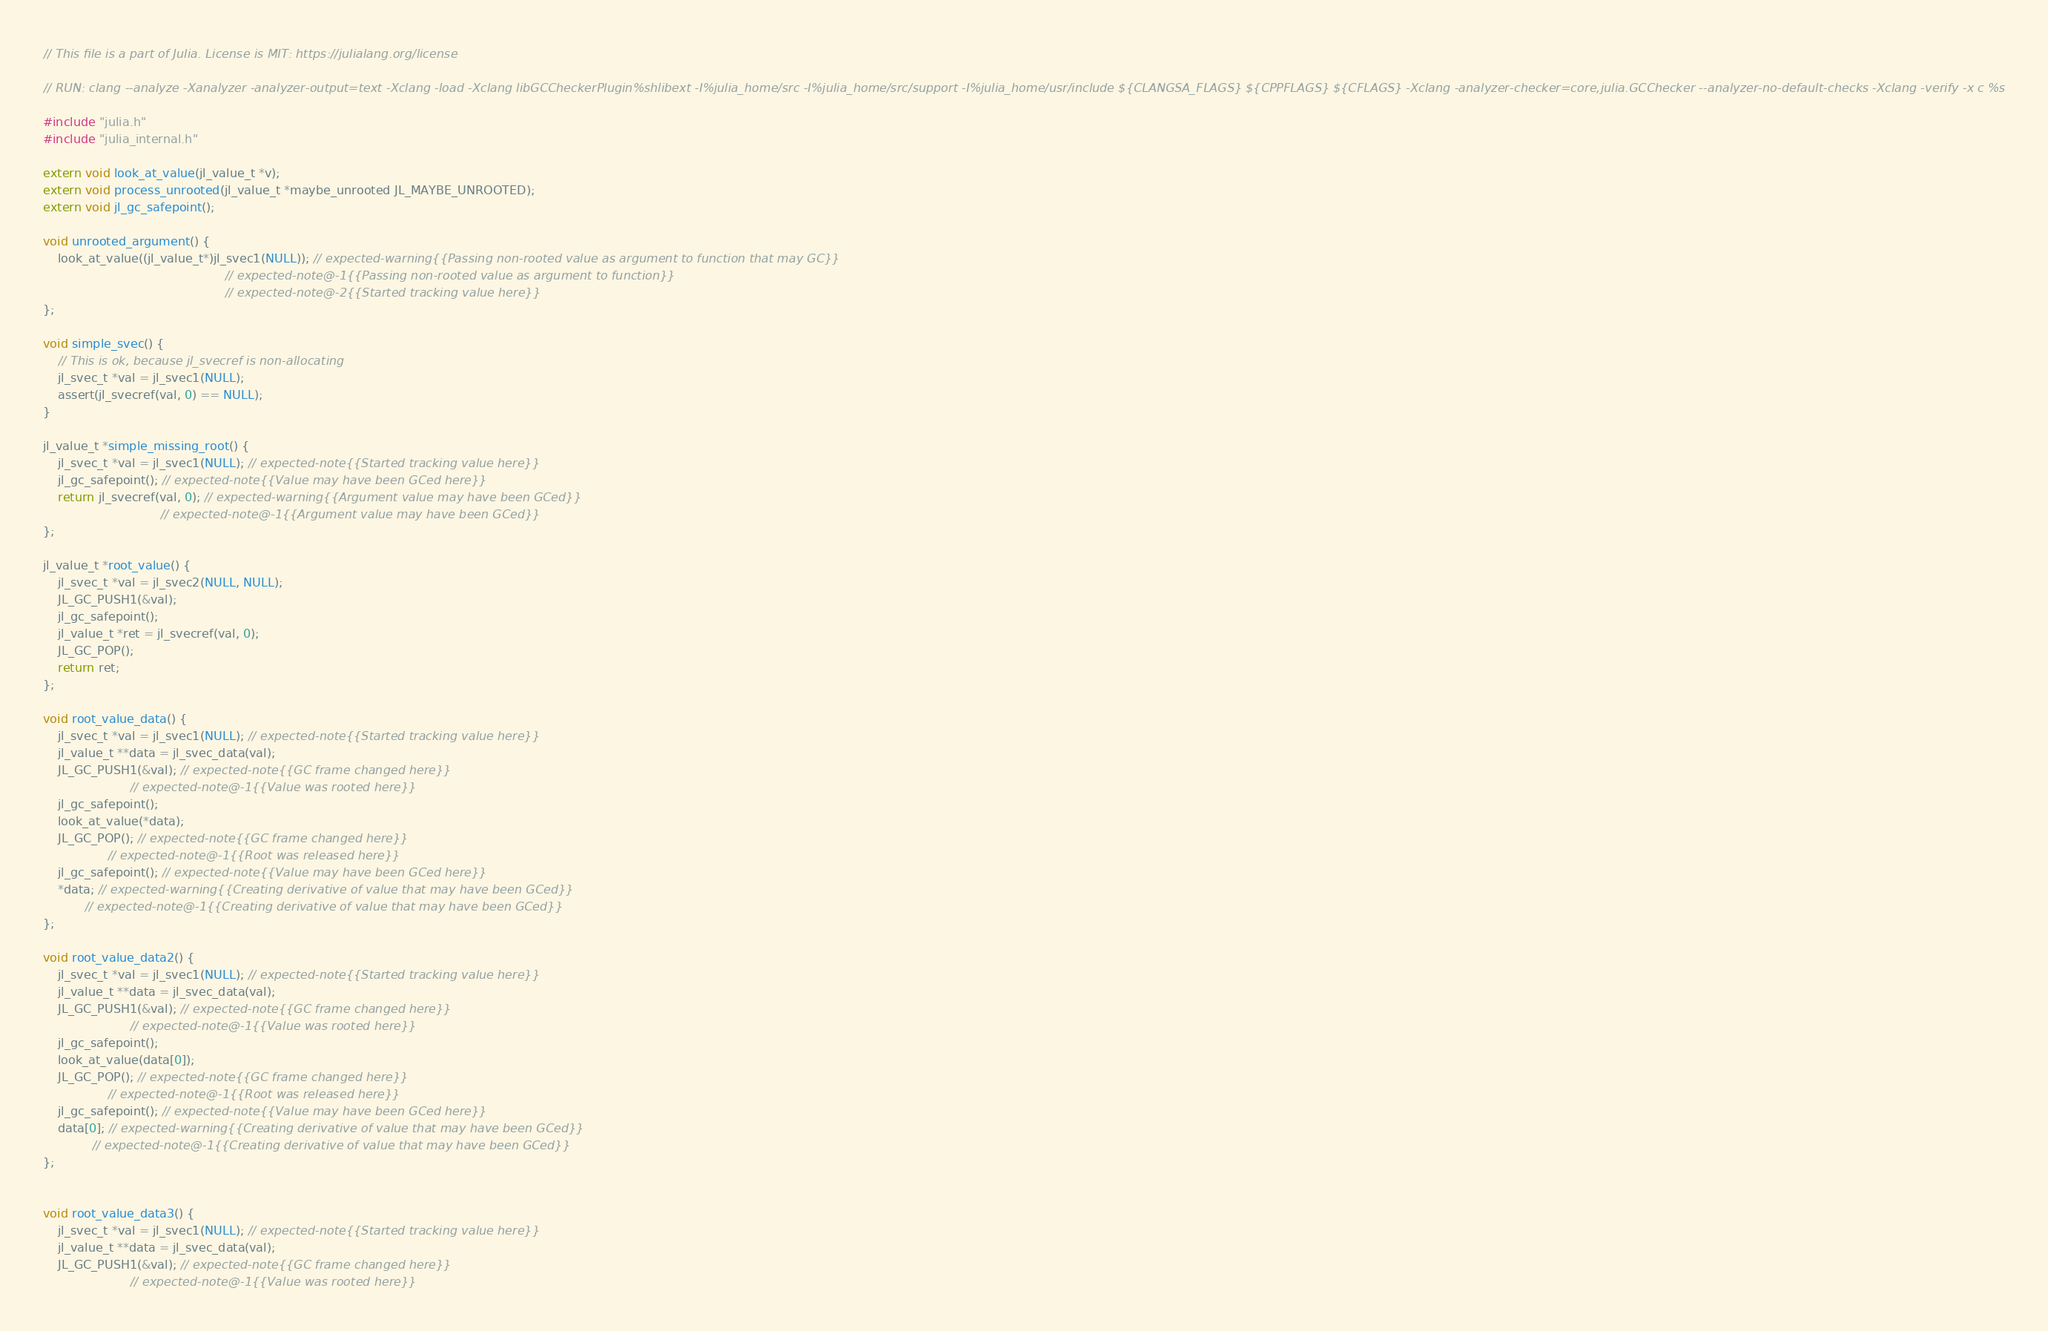<code> <loc_0><loc_0><loc_500><loc_500><_C_>// This file is a part of Julia. License is MIT: https://julialang.org/license

// RUN: clang --analyze -Xanalyzer -analyzer-output=text -Xclang -load -Xclang libGCCheckerPlugin%shlibext -I%julia_home/src -I%julia_home/src/support -I%julia_home/usr/include ${CLANGSA_FLAGS} ${CPPFLAGS} ${CFLAGS} -Xclang -analyzer-checker=core,julia.GCChecker --analyzer-no-default-checks -Xclang -verify -x c %s

#include "julia.h"
#include "julia_internal.h"

extern void look_at_value(jl_value_t *v);
extern void process_unrooted(jl_value_t *maybe_unrooted JL_MAYBE_UNROOTED);
extern void jl_gc_safepoint();

void unrooted_argument() {
    look_at_value((jl_value_t*)jl_svec1(NULL)); // expected-warning{{Passing non-rooted value as argument to function that may GC}}
                                                // expected-note@-1{{Passing non-rooted value as argument to function}}
                                                // expected-note@-2{{Started tracking value here}}
};

void simple_svec() {
    // This is ok, because jl_svecref is non-allocating
    jl_svec_t *val = jl_svec1(NULL);
    assert(jl_svecref(val, 0) == NULL);
}

jl_value_t *simple_missing_root() {
    jl_svec_t *val = jl_svec1(NULL); // expected-note{{Started tracking value here}}
    jl_gc_safepoint(); // expected-note{{Value may have been GCed here}}
    return jl_svecref(val, 0); // expected-warning{{Argument value may have been GCed}}
                               // expected-note@-1{{Argument value may have been GCed}}
};

jl_value_t *root_value() {
    jl_svec_t *val = jl_svec2(NULL, NULL);
    JL_GC_PUSH1(&val);
    jl_gc_safepoint();
    jl_value_t *ret = jl_svecref(val, 0);
    JL_GC_POP();
    return ret;
};

void root_value_data() {
    jl_svec_t *val = jl_svec1(NULL); // expected-note{{Started tracking value here}}
    jl_value_t **data = jl_svec_data(val);
    JL_GC_PUSH1(&val); // expected-note{{GC frame changed here}}
                       // expected-note@-1{{Value was rooted here}}
    jl_gc_safepoint();
    look_at_value(*data);
    JL_GC_POP(); // expected-note{{GC frame changed here}}
                 // expected-note@-1{{Root was released here}}
    jl_gc_safepoint(); // expected-note{{Value may have been GCed here}}
    *data; // expected-warning{{Creating derivative of value that may have been GCed}}
           // expected-note@-1{{Creating derivative of value that may have been GCed}}
};

void root_value_data2() {
    jl_svec_t *val = jl_svec1(NULL); // expected-note{{Started tracking value here}}
    jl_value_t **data = jl_svec_data(val);
    JL_GC_PUSH1(&val); // expected-note{{GC frame changed here}}
                       // expected-note@-1{{Value was rooted here}}
    jl_gc_safepoint();
    look_at_value(data[0]);
    JL_GC_POP(); // expected-note{{GC frame changed here}}
                 // expected-note@-1{{Root was released here}}
    jl_gc_safepoint(); // expected-note{{Value may have been GCed here}}
    data[0]; // expected-warning{{Creating derivative of value that may have been GCed}}
             // expected-note@-1{{Creating derivative of value that may have been GCed}}
};


void root_value_data3() {
    jl_svec_t *val = jl_svec1(NULL); // expected-note{{Started tracking value here}}
    jl_value_t **data = jl_svec_data(val);
    JL_GC_PUSH1(&val); // expected-note{{GC frame changed here}}
                       // expected-note@-1{{Value was rooted here}}</code> 